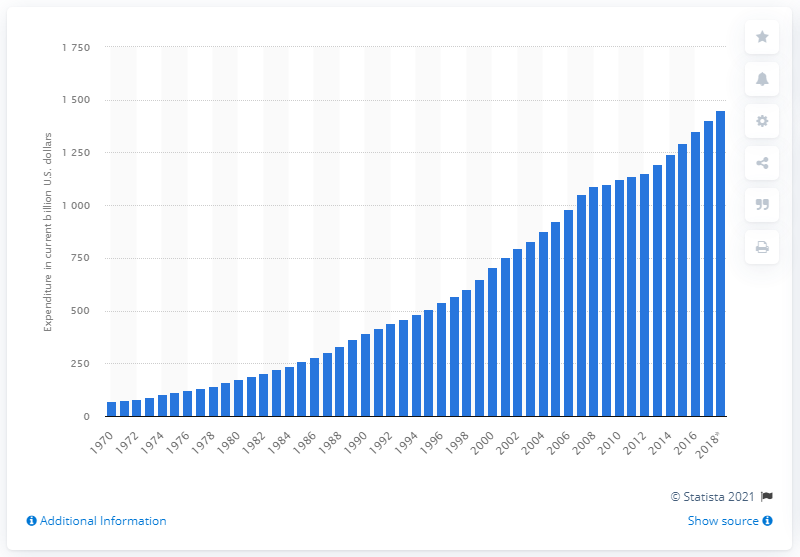Outline some significant characteristics in this image. In the 2018/2019 school year, a total of 1453 dollars were spent by both public and private schools in the United States. 